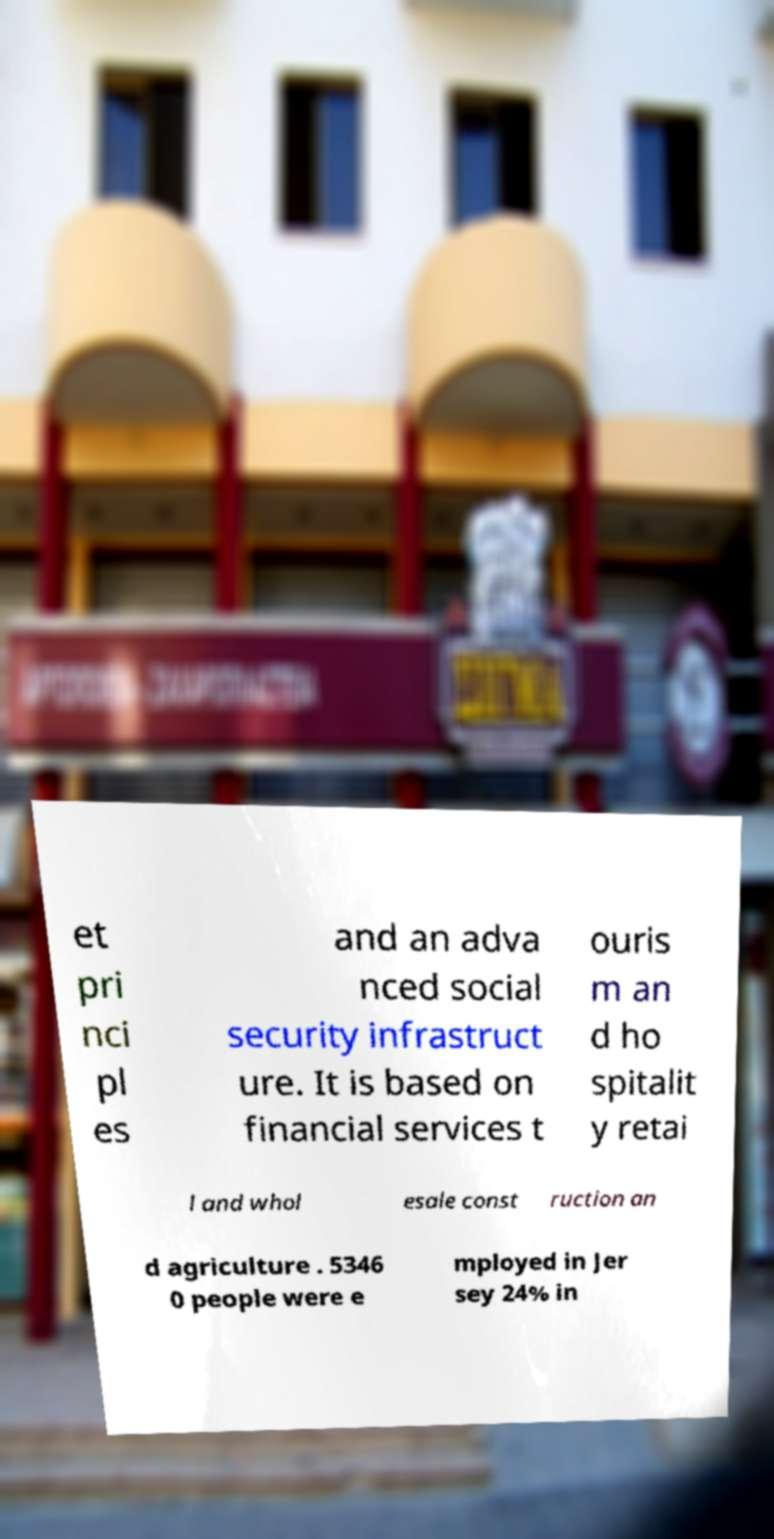There's text embedded in this image that I need extracted. Can you transcribe it verbatim? et pri nci pl es and an adva nced social security infrastruct ure. It is based on financial services t ouris m an d ho spitalit y retai l and whol esale const ruction an d agriculture . 5346 0 people were e mployed in Jer sey 24% in 